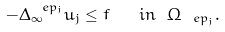<formula> <loc_0><loc_0><loc_500><loc_500>- \Delta _ { \infty } ^ { \ e p _ { j } } u _ { j } \leq f \quad i n \ \Omega _ { \ e p _ { j } } .</formula> 